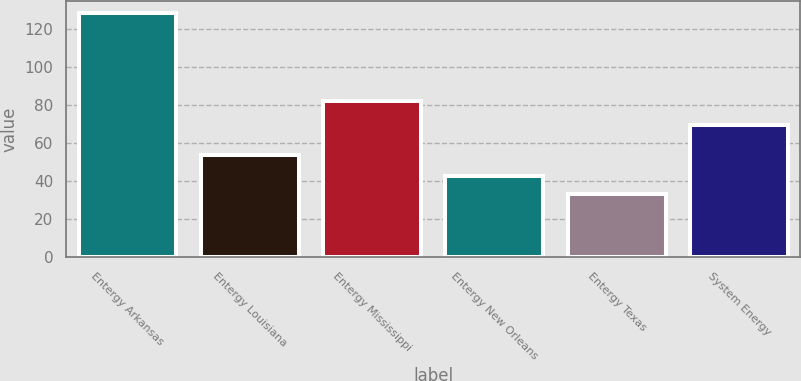Convert chart. <chart><loc_0><loc_0><loc_500><loc_500><bar_chart><fcel>Entergy Arkansas<fcel>Entergy Louisiana<fcel>Entergy Mississippi<fcel>Entergy New Orleans<fcel>Entergy Texas<fcel>System Energy<nl><fcel>128.5<fcel>53.9<fcel>82<fcel>43<fcel>33.5<fcel>69.7<nl></chart> 